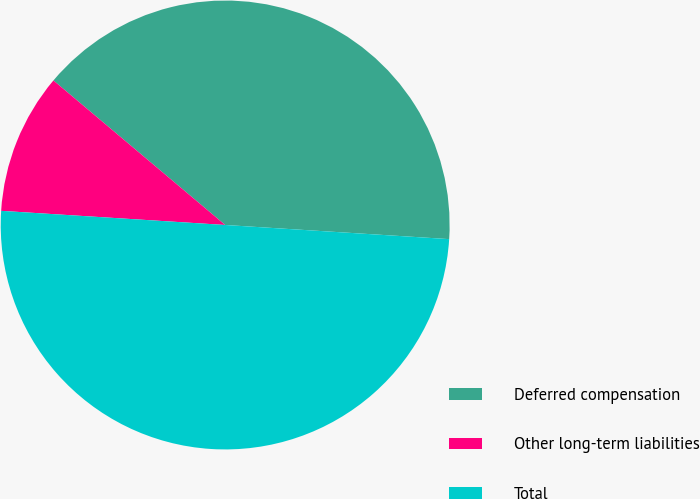Convert chart. <chart><loc_0><loc_0><loc_500><loc_500><pie_chart><fcel>Deferred compensation<fcel>Other long-term liabilities<fcel>Total<nl><fcel>39.87%<fcel>10.13%<fcel>50.0%<nl></chart> 